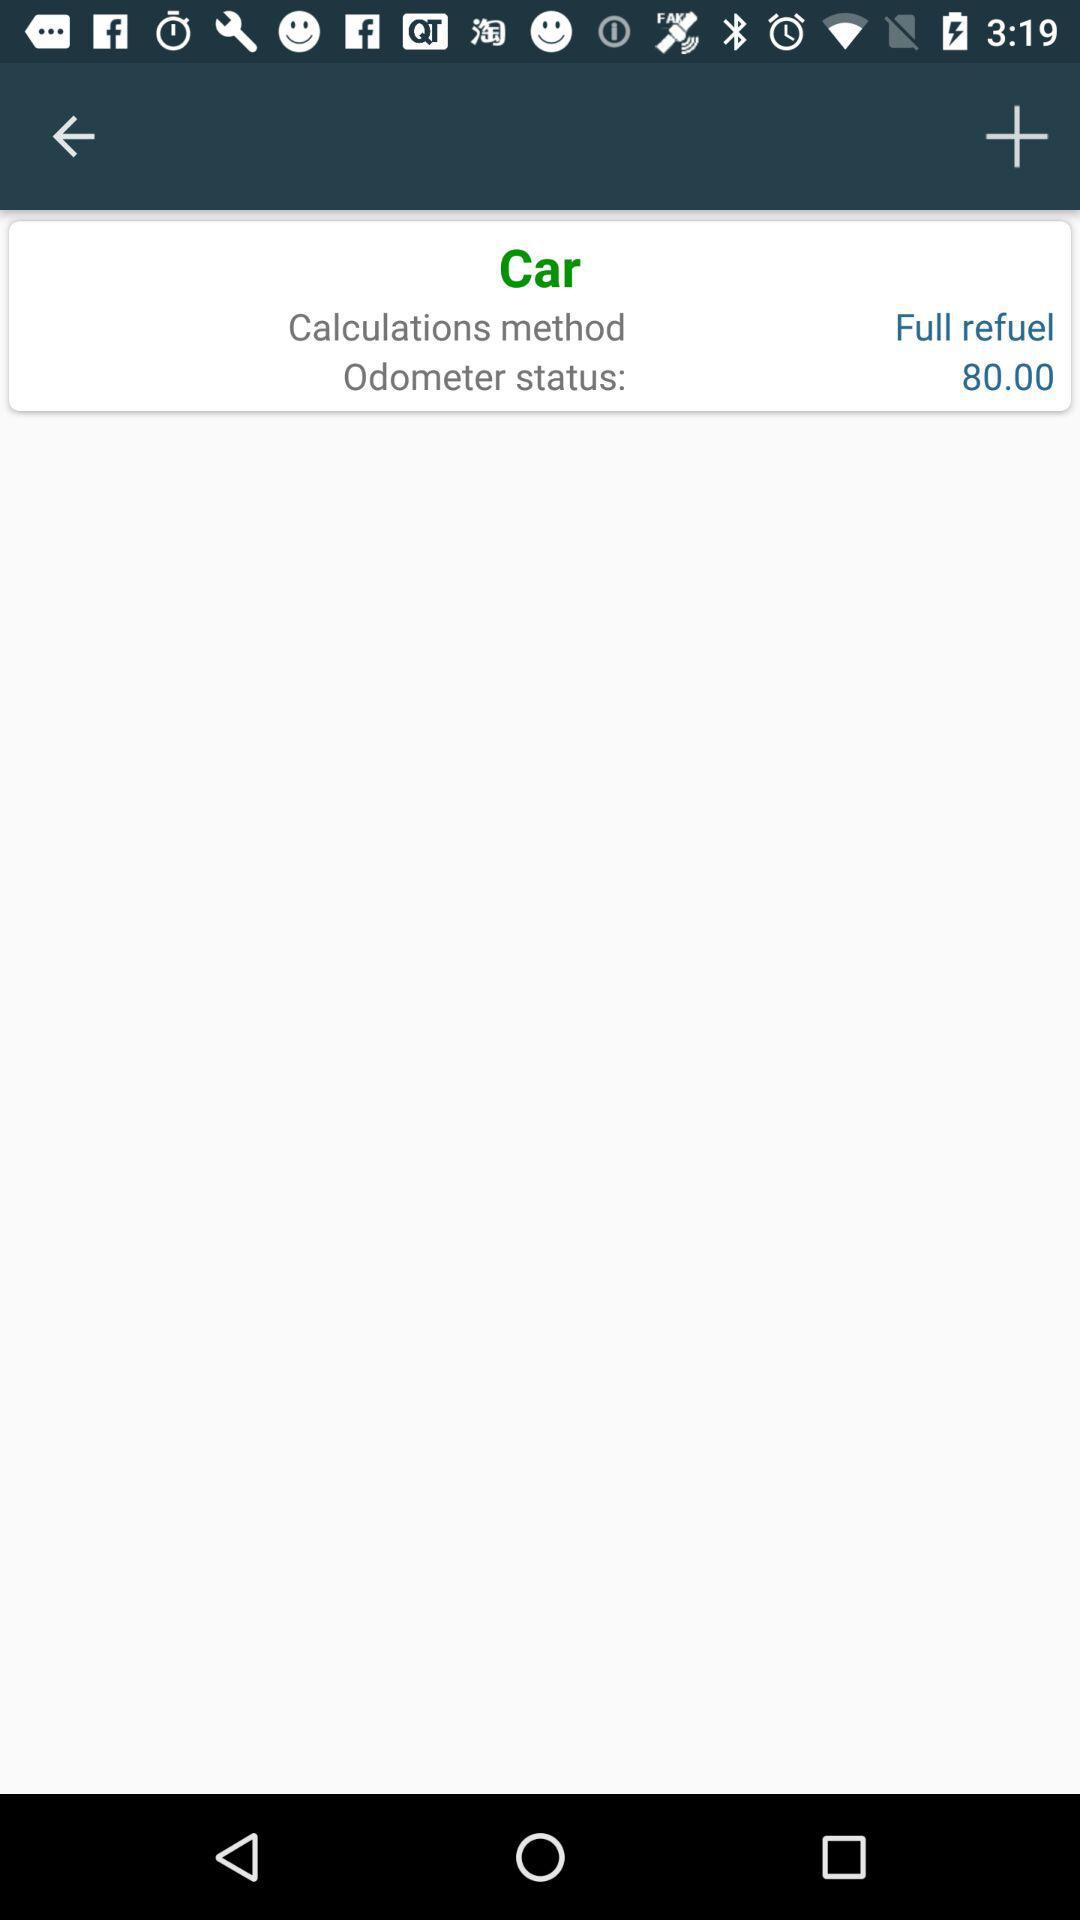What is the calculation method? The calculation method is "Full refuel". 